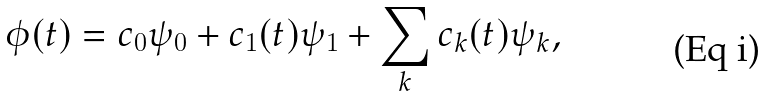<formula> <loc_0><loc_0><loc_500><loc_500>\phi ( t ) = c _ { 0 } \psi _ { 0 } + c _ { 1 } ( t ) \psi _ { 1 } + \sum _ { k } c _ { k } ( t ) \psi _ { k } ,</formula> 